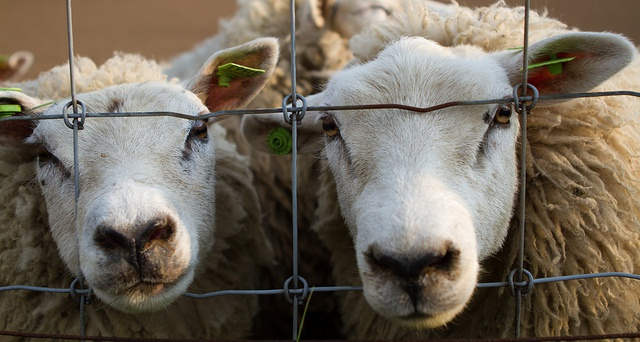Describe the objects in this image and their specific colors. I can see sheep in gray, black, and darkgray tones, sheep in gray, black, darkgray, and lightgray tones, and sheep in gray and darkgray tones in this image. 